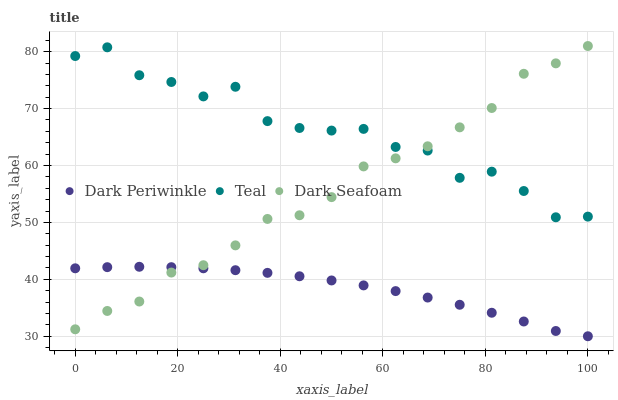Does Dark Periwinkle have the minimum area under the curve?
Answer yes or no. Yes. Does Teal have the maximum area under the curve?
Answer yes or no. Yes. Does Teal have the minimum area under the curve?
Answer yes or no. No. Does Dark Periwinkle have the maximum area under the curve?
Answer yes or no. No. Is Dark Periwinkle the smoothest?
Answer yes or no. Yes. Is Teal the roughest?
Answer yes or no. Yes. Is Teal the smoothest?
Answer yes or no. No. Is Dark Periwinkle the roughest?
Answer yes or no. No. Does Dark Periwinkle have the lowest value?
Answer yes or no. Yes. Does Teal have the lowest value?
Answer yes or no. No. Does Dark Seafoam have the highest value?
Answer yes or no. Yes. Does Teal have the highest value?
Answer yes or no. No. Is Dark Periwinkle less than Teal?
Answer yes or no. Yes. Is Teal greater than Dark Periwinkle?
Answer yes or no. Yes. Does Teal intersect Dark Seafoam?
Answer yes or no. Yes. Is Teal less than Dark Seafoam?
Answer yes or no. No. Is Teal greater than Dark Seafoam?
Answer yes or no. No. Does Dark Periwinkle intersect Teal?
Answer yes or no. No. 